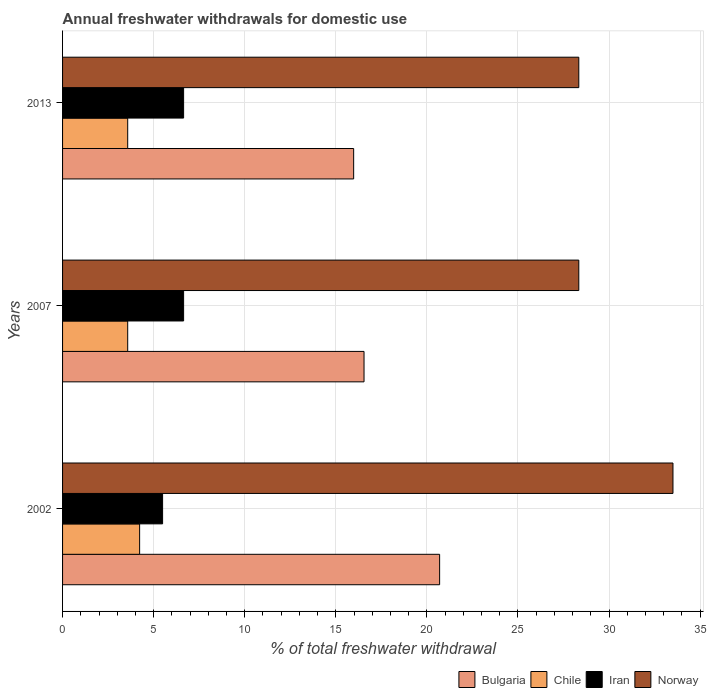How many different coloured bars are there?
Keep it short and to the point. 4. How many groups of bars are there?
Make the answer very short. 3. How many bars are there on the 1st tick from the bottom?
Keep it short and to the point. 4. What is the label of the 3rd group of bars from the top?
Provide a short and direct response. 2002. What is the total annual withdrawals from freshwater in Chile in 2013?
Offer a very short reply. 3.58. Across all years, what is the maximum total annual withdrawals from freshwater in Iran?
Offer a very short reply. 6.64. Across all years, what is the minimum total annual withdrawals from freshwater in Bulgaria?
Make the answer very short. 15.98. In which year was the total annual withdrawals from freshwater in Bulgaria minimum?
Give a very brief answer. 2013. What is the total total annual withdrawals from freshwater in Bulgaria in the graph?
Offer a very short reply. 53.23. What is the difference between the total annual withdrawals from freshwater in Iran in 2013 and the total annual withdrawals from freshwater in Norway in 2002?
Provide a succinct answer. -26.86. What is the average total annual withdrawals from freshwater in Norway per year?
Offer a very short reply. 30.06. In the year 2002, what is the difference between the total annual withdrawals from freshwater in Norway and total annual withdrawals from freshwater in Bulgaria?
Provide a short and direct response. 12.81. In how many years, is the total annual withdrawals from freshwater in Bulgaria greater than 6 %?
Offer a terse response. 3. What is the ratio of the total annual withdrawals from freshwater in Bulgaria in 2007 to that in 2013?
Your answer should be compact. 1.04. Is the total annual withdrawals from freshwater in Chile in 2002 less than that in 2013?
Give a very brief answer. No. What is the difference between the highest and the second highest total annual withdrawals from freshwater in Norway?
Keep it short and to the point. 5.17. What is the difference between the highest and the lowest total annual withdrawals from freshwater in Bulgaria?
Provide a succinct answer. 4.72. In how many years, is the total annual withdrawals from freshwater in Bulgaria greater than the average total annual withdrawals from freshwater in Bulgaria taken over all years?
Provide a succinct answer. 1. What does the 2nd bar from the top in 2002 represents?
Provide a short and direct response. Iran. Is it the case that in every year, the sum of the total annual withdrawals from freshwater in Norway and total annual withdrawals from freshwater in Iran is greater than the total annual withdrawals from freshwater in Bulgaria?
Give a very brief answer. Yes. How many bars are there?
Provide a short and direct response. 12. Are all the bars in the graph horizontal?
Your answer should be compact. Yes. What is the difference between two consecutive major ticks on the X-axis?
Ensure brevity in your answer.  5. Are the values on the major ticks of X-axis written in scientific E-notation?
Your answer should be compact. No. Where does the legend appear in the graph?
Your answer should be very brief. Bottom right. How many legend labels are there?
Make the answer very short. 4. What is the title of the graph?
Keep it short and to the point. Annual freshwater withdrawals for domestic use. Does "Costa Rica" appear as one of the legend labels in the graph?
Provide a succinct answer. No. What is the label or title of the X-axis?
Your response must be concise. % of total freshwater withdrawal. What is the % of total freshwater withdrawal in Bulgaria in 2002?
Give a very brief answer. 20.7. What is the % of total freshwater withdrawal in Chile in 2002?
Provide a succinct answer. 4.23. What is the % of total freshwater withdrawal of Iran in 2002?
Ensure brevity in your answer.  5.49. What is the % of total freshwater withdrawal of Norway in 2002?
Provide a short and direct response. 33.51. What is the % of total freshwater withdrawal in Bulgaria in 2007?
Offer a very short reply. 16.55. What is the % of total freshwater withdrawal of Chile in 2007?
Give a very brief answer. 3.58. What is the % of total freshwater withdrawal of Iran in 2007?
Offer a very short reply. 6.64. What is the % of total freshwater withdrawal of Norway in 2007?
Ensure brevity in your answer.  28.34. What is the % of total freshwater withdrawal of Bulgaria in 2013?
Offer a terse response. 15.98. What is the % of total freshwater withdrawal in Chile in 2013?
Your answer should be compact. 3.58. What is the % of total freshwater withdrawal of Iran in 2013?
Your answer should be compact. 6.64. What is the % of total freshwater withdrawal in Norway in 2013?
Provide a short and direct response. 28.34. Across all years, what is the maximum % of total freshwater withdrawal in Bulgaria?
Provide a short and direct response. 20.7. Across all years, what is the maximum % of total freshwater withdrawal in Chile?
Your answer should be very brief. 4.23. Across all years, what is the maximum % of total freshwater withdrawal in Iran?
Offer a very short reply. 6.64. Across all years, what is the maximum % of total freshwater withdrawal of Norway?
Provide a short and direct response. 33.51. Across all years, what is the minimum % of total freshwater withdrawal in Bulgaria?
Keep it short and to the point. 15.98. Across all years, what is the minimum % of total freshwater withdrawal of Chile?
Keep it short and to the point. 3.58. Across all years, what is the minimum % of total freshwater withdrawal in Iran?
Ensure brevity in your answer.  5.49. Across all years, what is the minimum % of total freshwater withdrawal of Norway?
Offer a very short reply. 28.34. What is the total % of total freshwater withdrawal in Bulgaria in the graph?
Offer a very short reply. 53.23. What is the total % of total freshwater withdrawal in Chile in the graph?
Give a very brief answer. 11.38. What is the total % of total freshwater withdrawal in Iran in the graph?
Keep it short and to the point. 18.78. What is the total % of total freshwater withdrawal of Norway in the graph?
Keep it short and to the point. 90.19. What is the difference between the % of total freshwater withdrawal in Bulgaria in 2002 and that in 2007?
Make the answer very short. 4.15. What is the difference between the % of total freshwater withdrawal of Chile in 2002 and that in 2007?
Your answer should be very brief. 0.65. What is the difference between the % of total freshwater withdrawal of Iran in 2002 and that in 2007?
Give a very brief answer. -1.15. What is the difference between the % of total freshwater withdrawal of Norway in 2002 and that in 2007?
Offer a very short reply. 5.17. What is the difference between the % of total freshwater withdrawal of Bulgaria in 2002 and that in 2013?
Make the answer very short. 4.72. What is the difference between the % of total freshwater withdrawal of Chile in 2002 and that in 2013?
Offer a terse response. 0.65. What is the difference between the % of total freshwater withdrawal of Iran in 2002 and that in 2013?
Offer a terse response. -1.15. What is the difference between the % of total freshwater withdrawal in Norway in 2002 and that in 2013?
Offer a terse response. 5.17. What is the difference between the % of total freshwater withdrawal in Bulgaria in 2007 and that in 2013?
Your answer should be compact. 0.57. What is the difference between the % of total freshwater withdrawal in Chile in 2007 and that in 2013?
Give a very brief answer. 0. What is the difference between the % of total freshwater withdrawal in Iran in 2007 and that in 2013?
Offer a very short reply. 0. What is the difference between the % of total freshwater withdrawal in Norway in 2007 and that in 2013?
Provide a short and direct response. 0. What is the difference between the % of total freshwater withdrawal in Bulgaria in 2002 and the % of total freshwater withdrawal in Chile in 2007?
Your response must be concise. 17.12. What is the difference between the % of total freshwater withdrawal in Bulgaria in 2002 and the % of total freshwater withdrawal in Iran in 2007?
Offer a terse response. 14.05. What is the difference between the % of total freshwater withdrawal of Bulgaria in 2002 and the % of total freshwater withdrawal of Norway in 2007?
Provide a succinct answer. -7.64. What is the difference between the % of total freshwater withdrawal in Chile in 2002 and the % of total freshwater withdrawal in Iran in 2007?
Give a very brief answer. -2.42. What is the difference between the % of total freshwater withdrawal in Chile in 2002 and the % of total freshwater withdrawal in Norway in 2007?
Give a very brief answer. -24.11. What is the difference between the % of total freshwater withdrawal of Iran in 2002 and the % of total freshwater withdrawal of Norway in 2007?
Your answer should be very brief. -22.85. What is the difference between the % of total freshwater withdrawal of Bulgaria in 2002 and the % of total freshwater withdrawal of Chile in 2013?
Make the answer very short. 17.12. What is the difference between the % of total freshwater withdrawal in Bulgaria in 2002 and the % of total freshwater withdrawal in Iran in 2013?
Your response must be concise. 14.05. What is the difference between the % of total freshwater withdrawal in Bulgaria in 2002 and the % of total freshwater withdrawal in Norway in 2013?
Offer a very short reply. -7.64. What is the difference between the % of total freshwater withdrawal in Chile in 2002 and the % of total freshwater withdrawal in Iran in 2013?
Give a very brief answer. -2.42. What is the difference between the % of total freshwater withdrawal of Chile in 2002 and the % of total freshwater withdrawal of Norway in 2013?
Give a very brief answer. -24.11. What is the difference between the % of total freshwater withdrawal in Iran in 2002 and the % of total freshwater withdrawal in Norway in 2013?
Your answer should be very brief. -22.85. What is the difference between the % of total freshwater withdrawal of Bulgaria in 2007 and the % of total freshwater withdrawal of Chile in 2013?
Your response must be concise. 12.97. What is the difference between the % of total freshwater withdrawal in Bulgaria in 2007 and the % of total freshwater withdrawal in Iran in 2013?
Keep it short and to the point. 9.9. What is the difference between the % of total freshwater withdrawal in Bulgaria in 2007 and the % of total freshwater withdrawal in Norway in 2013?
Make the answer very short. -11.79. What is the difference between the % of total freshwater withdrawal in Chile in 2007 and the % of total freshwater withdrawal in Iran in 2013?
Provide a short and direct response. -3.07. What is the difference between the % of total freshwater withdrawal in Chile in 2007 and the % of total freshwater withdrawal in Norway in 2013?
Your answer should be very brief. -24.76. What is the difference between the % of total freshwater withdrawal in Iran in 2007 and the % of total freshwater withdrawal in Norway in 2013?
Your answer should be compact. -21.7. What is the average % of total freshwater withdrawal in Bulgaria per year?
Offer a terse response. 17.74. What is the average % of total freshwater withdrawal of Chile per year?
Offer a terse response. 3.79. What is the average % of total freshwater withdrawal of Iran per year?
Your answer should be compact. 6.26. What is the average % of total freshwater withdrawal of Norway per year?
Make the answer very short. 30.06. In the year 2002, what is the difference between the % of total freshwater withdrawal in Bulgaria and % of total freshwater withdrawal in Chile?
Provide a short and direct response. 16.47. In the year 2002, what is the difference between the % of total freshwater withdrawal in Bulgaria and % of total freshwater withdrawal in Iran?
Offer a terse response. 15.21. In the year 2002, what is the difference between the % of total freshwater withdrawal in Bulgaria and % of total freshwater withdrawal in Norway?
Provide a succinct answer. -12.81. In the year 2002, what is the difference between the % of total freshwater withdrawal of Chile and % of total freshwater withdrawal of Iran?
Offer a very short reply. -1.26. In the year 2002, what is the difference between the % of total freshwater withdrawal in Chile and % of total freshwater withdrawal in Norway?
Your answer should be compact. -29.28. In the year 2002, what is the difference between the % of total freshwater withdrawal of Iran and % of total freshwater withdrawal of Norway?
Provide a short and direct response. -28.02. In the year 2007, what is the difference between the % of total freshwater withdrawal in Bulgaria and % of total freshwater withdrawal in Chile?
Your answer should be very brief. 12.97. In the year 2007, what is the difference between the % of total freshwater withdrawal in Bulgaria and % of total freshwater withdrawal in Iran?
Offer a very short reply. 9.9. In the year 2007, what is the difference between the % of total freshwater withdrawal of Bulgaria and % of total freshwater withdrawal of Norway?
Offer a terse response. -11.79. In the year 2007, what is the difference between the % of total freshwater withdrawal of Chile and % of total freshwater withdrawal of Iran?
Keep it short and to the point. -3.07. In the year 2007, what is the difference between the % of total freshwater withdrawal of Chile and % of total freshwater withdrawal of Norway?
Ensure brevity in your answer.  -24.76. In the year 2007, what is the difference between the % of total freshwater withdrawal of Iran and % of total freshwater withdrawal of Norway?
Provide a short and direct response. -21.7. In the year 2013, what is the difference between the % of total freshwater withdrawal in Bulgaria and % of total freshwater withdrawal in Chile?
Ensure brevity in your answer.  12.4. In the year 2013, what is the difference between the % of total freshwater withdrawal in Bulgaria and % of total freshwater withdrawal in Iran?
Ensure brevity in your answer.  9.34. In the year 2013, what is the difference between the % of total freshwater withdrawal in Bulgaria and % of total freshwater withdrawal in Norway?
Your response must be concise. -12.36. In the year 2013, what is the difference between the % of total freshwater withdrawal in Chile and % of total freshwater withdrawal in Iran?
Offer a very short reply. -3.07. In the year 2013, what is the difference between the % of total freshwater withdrawal in Chile and % of total freshwater withdrawal in Norway?
Ensure brevity in your answer.  -24.76. In the year 2013, what is the difference between the % of total freshwater withdrawal of Iran and % of total freshwater withdrawal of Norway?
Your answer should be compact. -21.7. What is the ratio of the % of total freshwater withdrawal of Bulgaria in 2002 to that in 2007?
Give a very brief answer. 1.25. What is the ratio of the % of total freshwater withdrawal in Chile in 2002 to that in 2007?
Your response must be concise. 1.18. What is the ratio of the % of total freshwater withdrawal in Iran in 2002 to that in 2007?
Make the answer very short. 0.83. What is the ratio of the % of total freshwater withdrawal of Norway in 2002 to that in 2007?
Keep it short and to the point. 1.18. What is the ratio of the % of total freshwater withdrawal in Bulgaria in 2002 to that in 2013?
Your answer should be compact. 1.3. What is the ratio of the % of total freshwater withdrawal in Chile in 2002 to that in 2013?
Offer a terse response. 1.18. What is the ratio of the % of total freshwater withdrawal of Iran in 2002 to that in 2013?
Your response must be concise. 0.83. What is the ratio of the % of total freshwater withdrawal of Norway in 2002 to that in 2013?
Offer a terse response. 1.18. What is the ratio of the % of total freshwater withdrawal in Bulgaria in 2007 to that in 2013?
Your response must be concise. 1.04. What is the ratio of the % of total freshwater withdrawal of Chile in 2007 to that in 2013?
Your answer should be very brief. 1. What is the difference between the highest and the second highest % of total freshwater withdrawal of Bulgaria?
Offer a very short reply. 4.15. What is the difference between the highest and the second highest % of total freshwater withdrawal in Chile?
Keep it short and to the point. 0.65. What is the difference between the highest and the second highest % of total freshwater withdrawal in Norway?
Keep it short and to the point. 5.17. What is the difference between the highest and the lowest % of total freshwater withdrawal of Bulgaria?
Ensure brevity in your answer.  4.72. What is the difference between the highest and the lowest % of total freshwater withdrawal of Chile?
Your answer should be very brief. 0.65. What is the difference between the highest and the lowest % of total freshwater withdrawal in Iran?
Your answer should be very brief. 1.15. What is the difference between the highest and the lowest % of total freshwater withdrawal in Norway?
Your response must be concise. 5.17. 